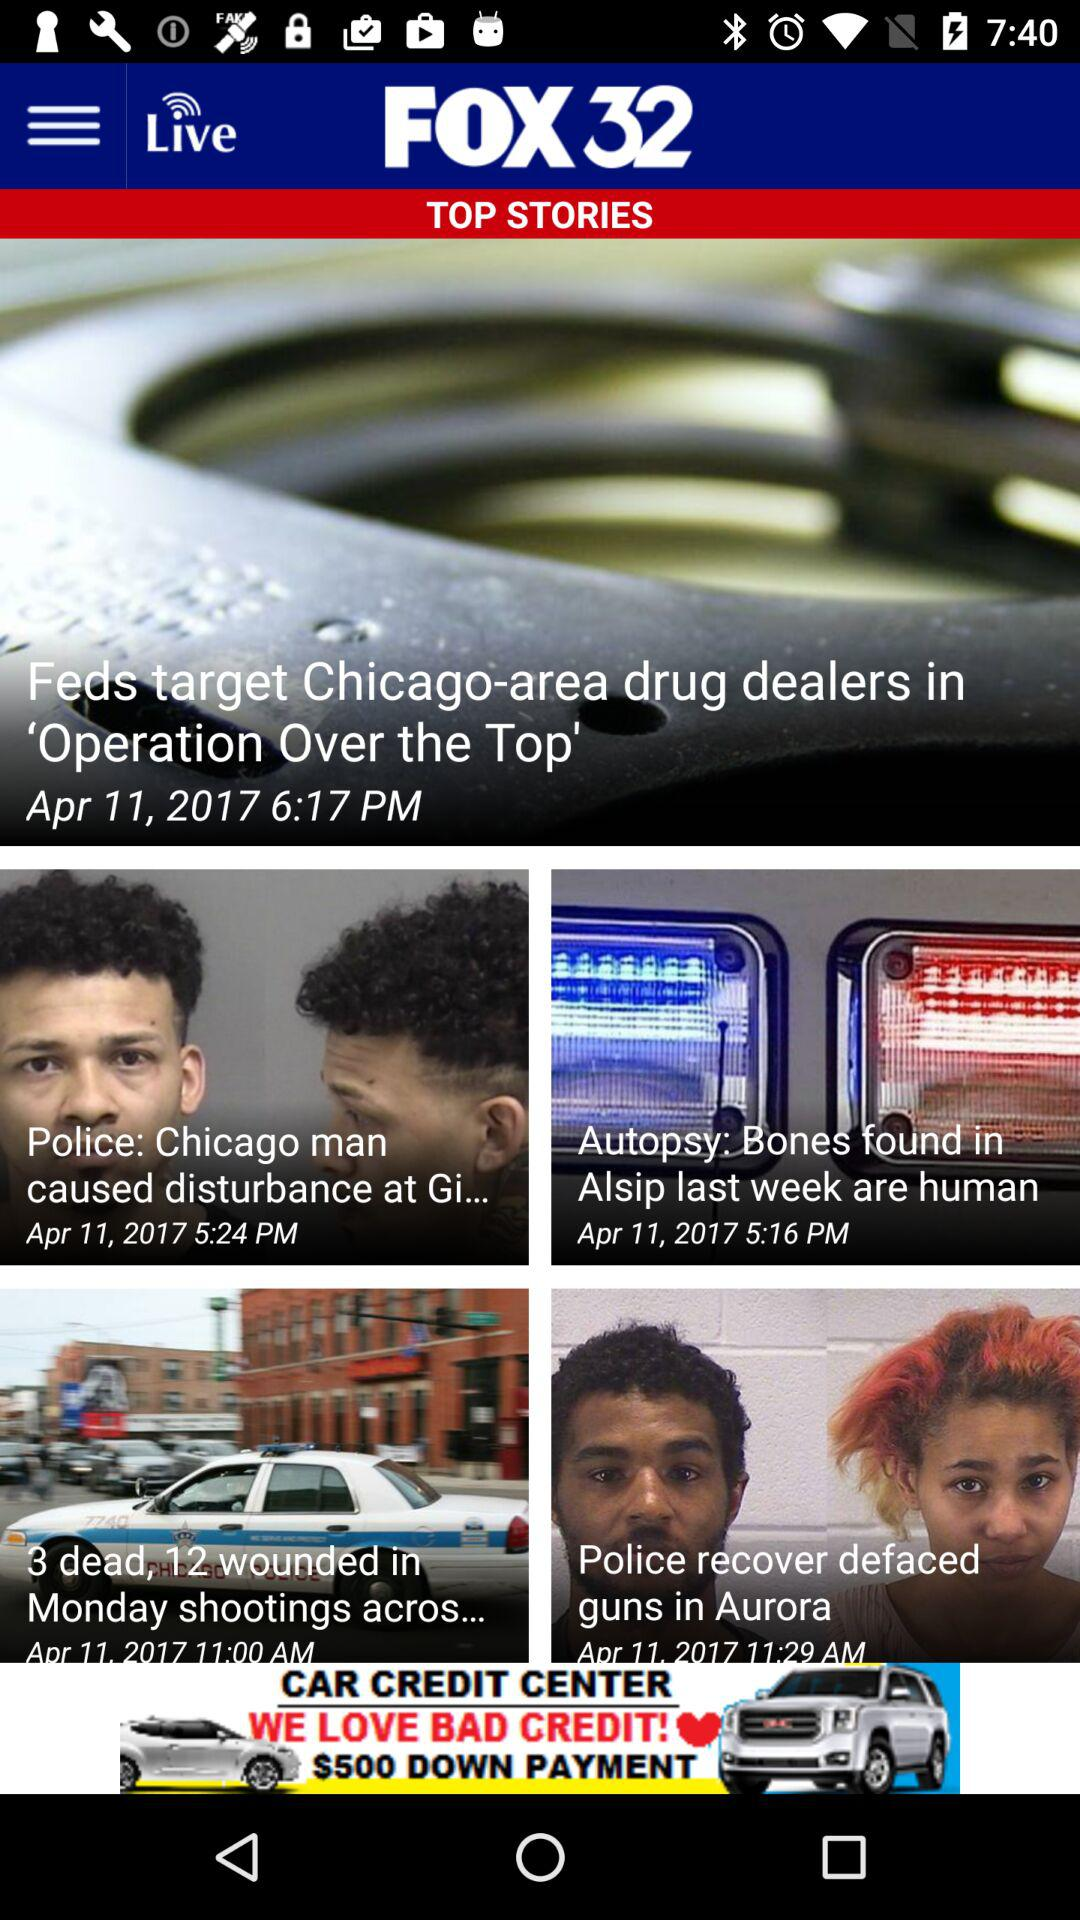What is the posted date for all news? The posted date for all news is April 11, 2017. 